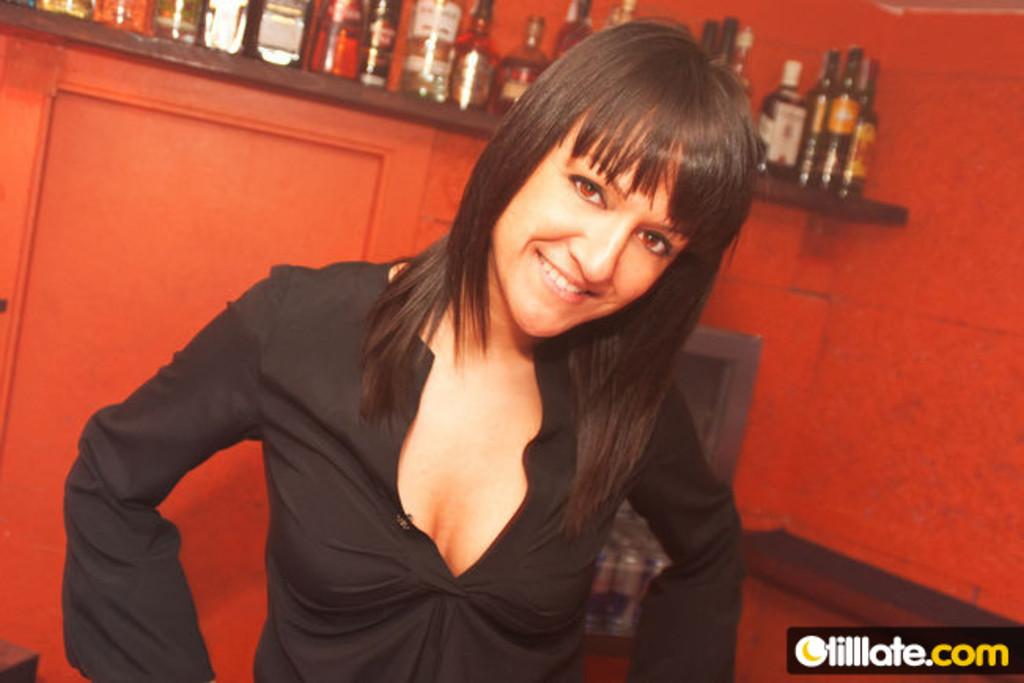Who is present in the image? There is a woman in the image. What is the woman's expression? The woman is smiling. What objects can be seen on the desk in the image? There are bottles visible on a desk in the image. What is written or displayed in the bottom right of the image? There is text in the bottom right of the image. What can be seen in the background of the image? There is a colorful wall in the background of the image. How does the woman shake hands with the brick in the image? There is no brick present in the image, and therefore no handshake can be observed. 